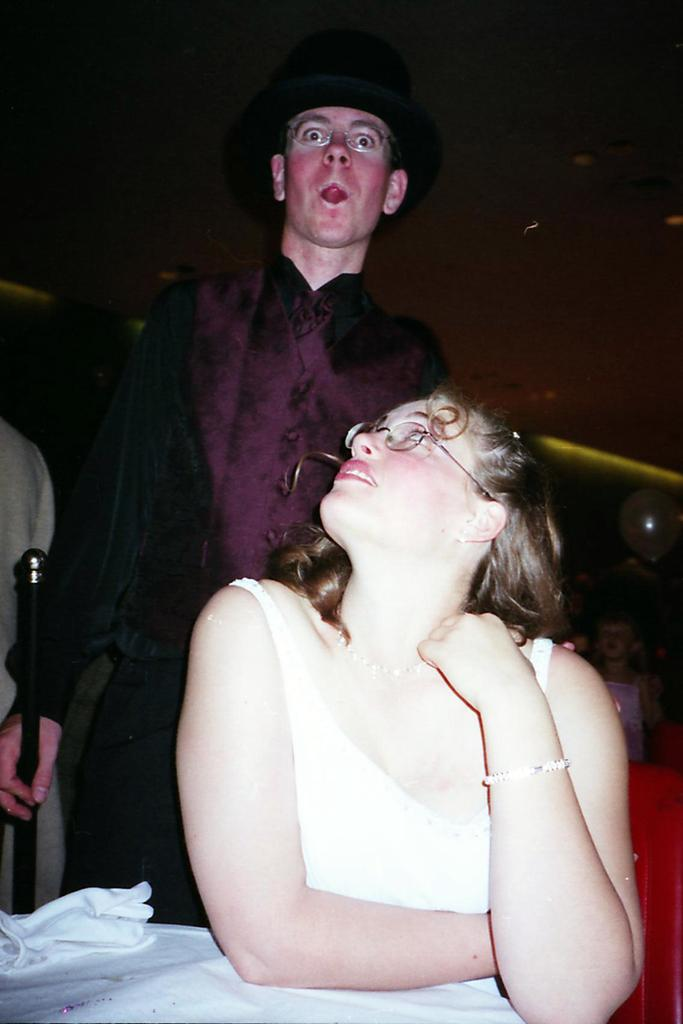How many people are in the image? There are people in the image, but the exact number is not specified. What can be seen besides the people in the image? There is a stick and clothes visible in the image. Can you describe the unspecified objects in the image? Unfortunately, the facts provided do not give any details about the unspecified objects in the image. What type of locket is the giraffe wearing around its neck in the image? There is no giraffe present in the image, and therefore no such locket can be observed. 